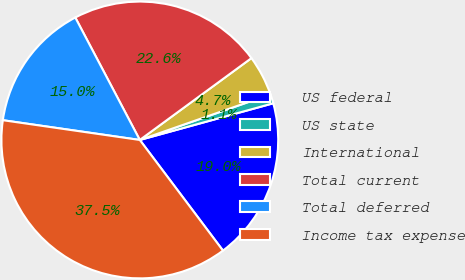Convert chart to OTSL. <chart><loc_0><loc_0><loc_500><loc_500><pie_chart><fcel>US federal<fcel>US state<fcel>International<fcel>Total current<fcel>Total deferred<fcel>Income tax expense<nl><fcel>19.01%<fcel>1.08%<fcel>4.72%<fcel>22.65%<fcel>15.0%<fcel>37.54%<nl></chart> 